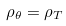Convert formula to latex. <formula><loc_0><loc_0><loc_500><loc_500>\rho _ { \theta } = \rho _ { T }</formula> 